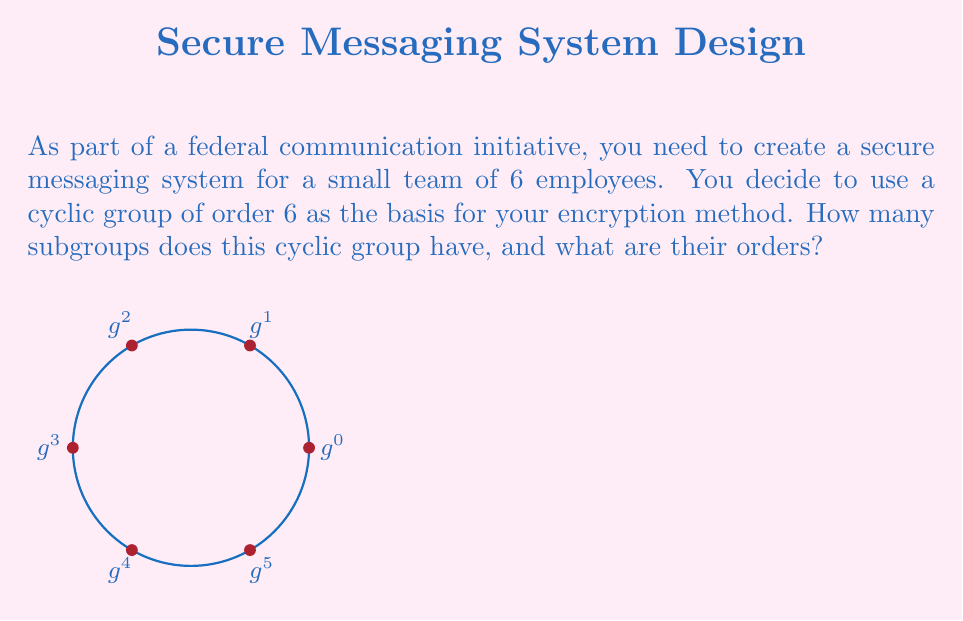What is the answer to this math problem? Let's approach this step-by-step:

1) First, recall that a cyclic group of order 6 is isomorphic to $\mathbb{Z}_6$, the group of integers modulo 6.

2) In a cyclic group, the number and orders of subgroups are determined by the divisors of the group's order. The divisors of 6 are 1, 2, 3, and 6.

3) For each divisor $d$ of 6, there is exactly one subgroup of order $d$. This is because:
   - The subgroup generated by $g^{6/d}$ has order $d$, where $g$ is a generator of the group.
   - There can't be more than one subgroup of each order in a cyclic group.

4) Let's identify these subgroups:
   - For $d=1$: The trivial subgroup $\{e\}$ or $\{g^0\}$
   - For $d=2$: The subgroup $\{e, g^3\}$ or $\{g^0, g^3\}$
   - For $d=3$: The subgroup $\{e, g^2, g^4\}$ or $\{g^0, g^2, g^4\}$
   - For $d=6$: The entire group $\{e, g, g^2, g^3, g^4, g^5\}$

5) Therefore, there are 4 subgroups in total, with orders 1, 2, 3, and 6.
Answer: 4 subgroups: orders 1, 2, 3, 6 